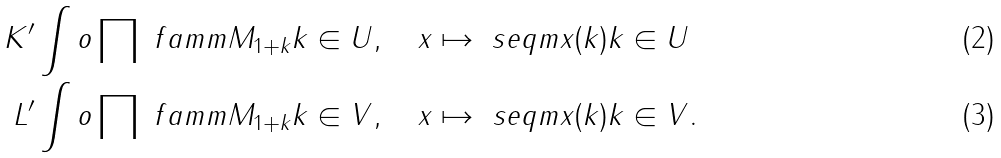<formula> <loc_0><loc_0><loc_500><loc_500>K ^ { \prime } & \int o \prod \ f a m m { M _ { 1 + k } } { k \in U } , \quad x \mapsto \ s e q m { x ( k ) } { k \in U } \\ L ^ { \prime } & \int o \prod \ f a m m { M _ { 1 + k } } { k \in V } , \quad x \mapsto \ s e q m { x ( k ) } { k \in V } .</formula> 